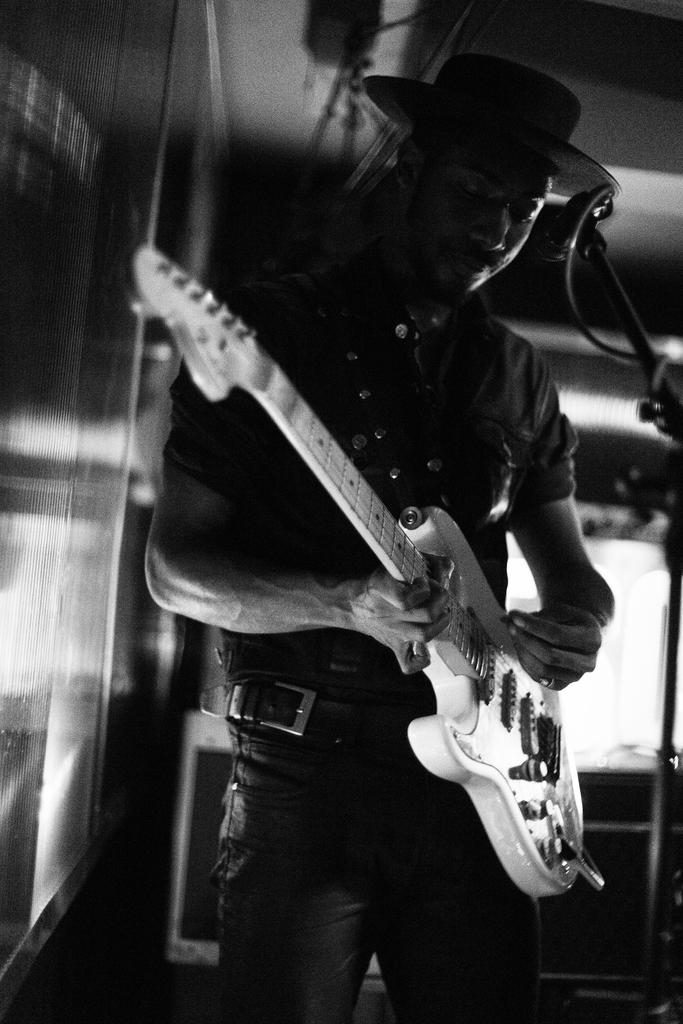What is the main subject of the image? There is a man in the image. What is the man doing in the image? The man is standing in the image. What object is the man holding in his hand? The man is holding a guitar in his hand. What type of hand is the man offering in the image? There is no hand being offered in the image; the man is holding a guitar. What is the man doing with his mouth in the image? The image does not show the man's mouth, so it cannot be determined what he is doing with it. 